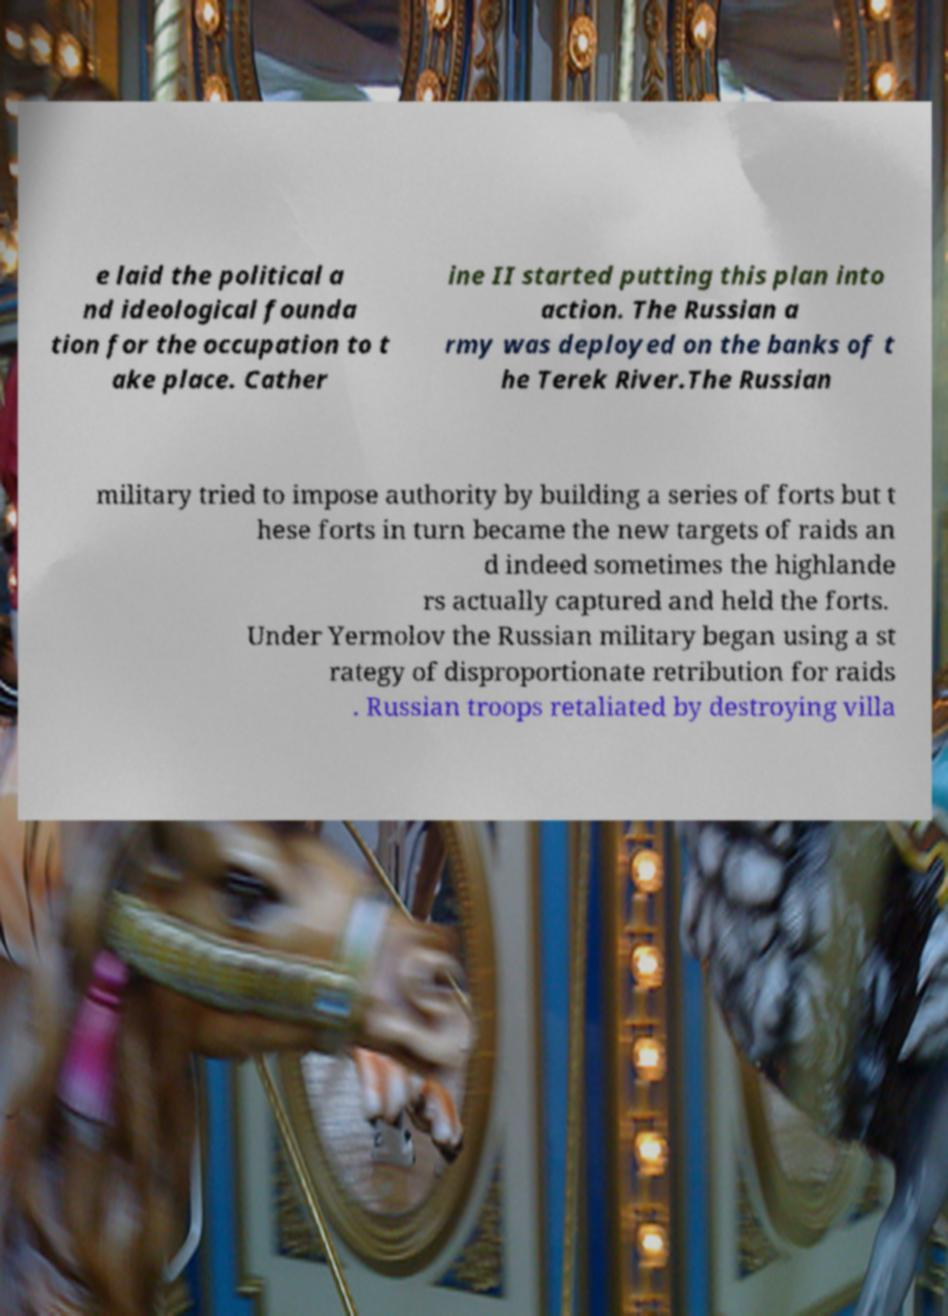I need the written content from this picture converted into text. Can you do that? e laid the political a nd ideological founda tion for the occupation to t ake place. Cather ine II started putting this plan into action. The Russian a rmy was deployed on the banks of t he Terek River.The Russian military tried to impose authority by building a series of forts but t hese forts in turn became the new targets of raids an d indeed sometimes the highlande rs actually captured and held the forts. Under Yermolov the Russian military began using a st rategy of disproportionate retribution for raids . Russian troops retaliated by destroying villa 